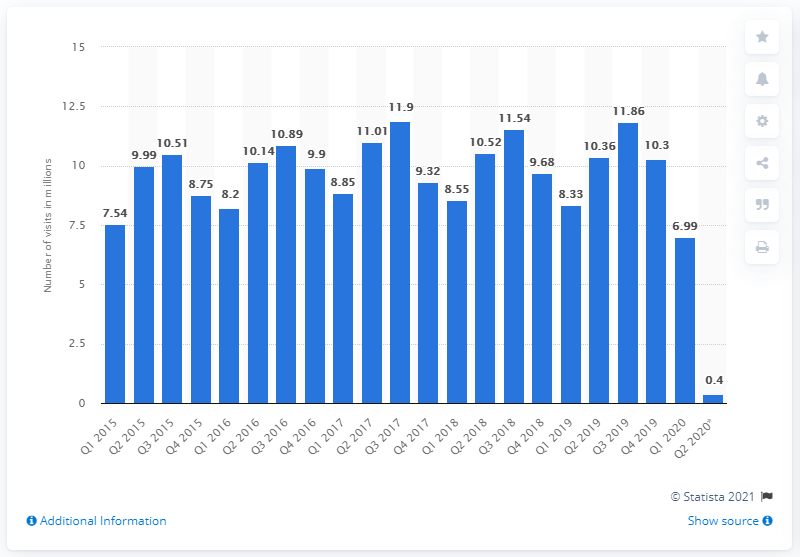Point out several critical features in this image. In the period between April and June 2020, the UK recorded a total of 0.4 inbound visits. 